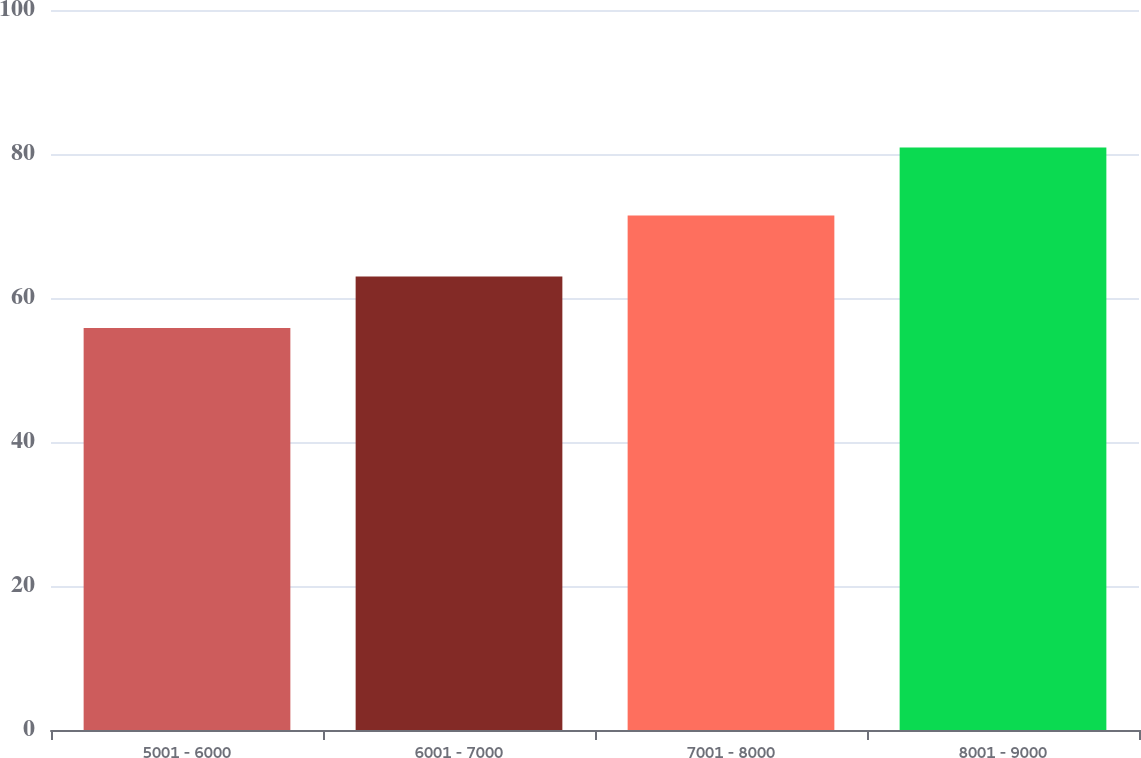<chart> <loc_0><loc_0><loc_500><loc_500><bar_chart><fcel>5001 - 6000<fcel>6001 - 7000<fcel>7001 - 8000<fcel>8001 - 9000<nl><fcel>55.83<fcel>62.98<fcel>71.47<fcel>80.92<nl></chart> 